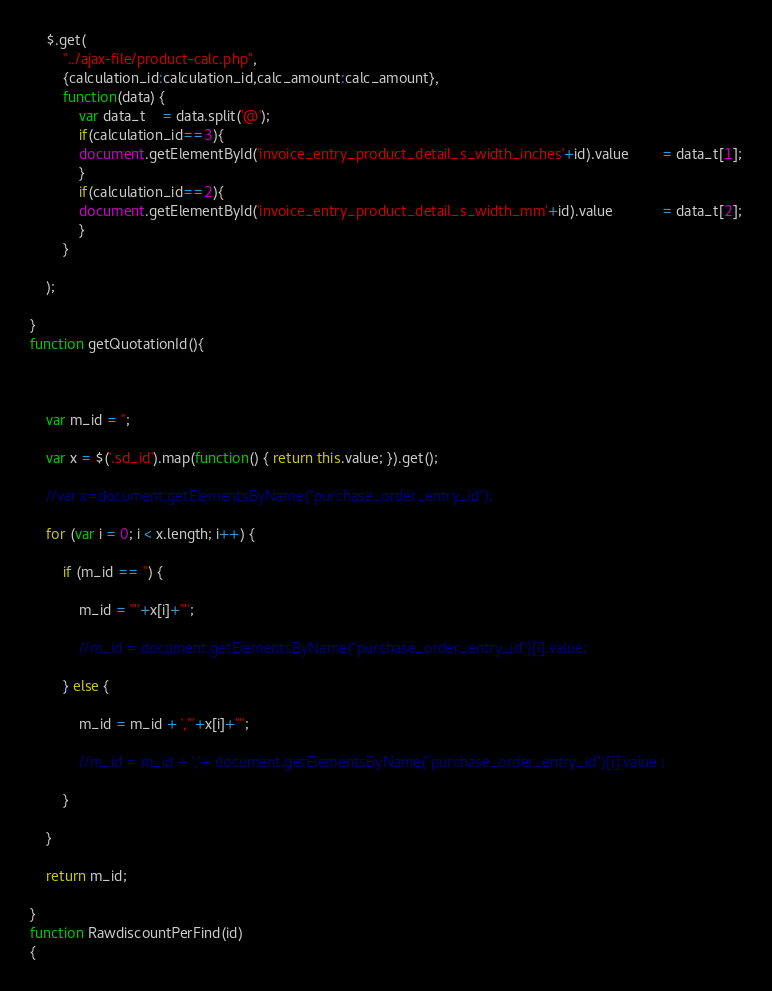Convert code to text. <code><loc_0><loc_0><loc_500><loc_500><_JavaScript_>
	$.get(
		"../ajax-file/product-calc.php",
		{calculation_id:calculation_id,calc_amount:calc_amount},
		function(data) {
			var data_t	= data.split('@'); 
			if(calculation_id==3){
			document.getElementById('invoice_entry_product_detail_s_width_inches'+id).value 		= data_t[1];
			}
			if(calculation_id==2){
			document.getElementById('invoice_entry_product_detail_s_width_mm'+id).value 			= data_t[2];
			}
		}

	);

}
function getQuotationId(){

	

	var m_id = '';

	var x = $('.sd_id').map(function() { return this.value; }).get();

    //var x=document.getElementsByName("purchase_order_entry_id");

	for (var i = 0; i < x.length; i++) {

		if (m_id == '') {

			m_id = '"'+x[i]+'"';

			//m_id = document.getElementsByName("purchase_order_entry_id")[i].value;

		} else {

			m_id = m_id + ',"'+x[i]+'"';

			//m_id = m_id + ','+ document.getElementsByName("purchase_order_entry_id")[i].value ;

		}

	}

	return m_id;

}
function RawdiscountPerFind(id)
{	</code> 